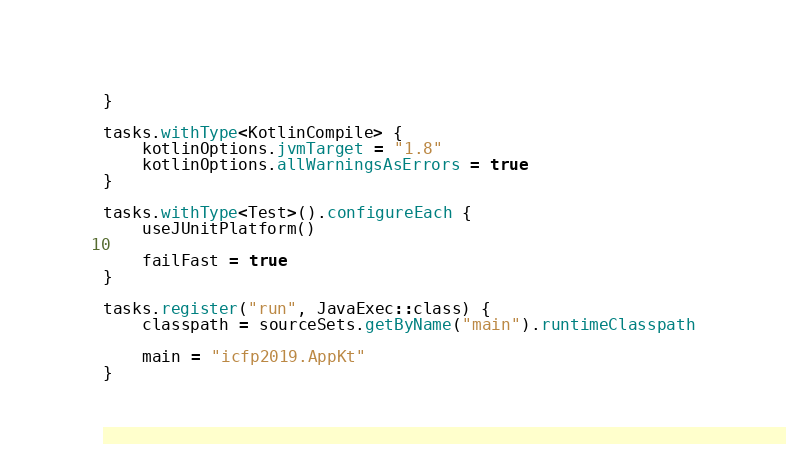Convert code to text. <code><loc_0><loc_0><loc_500><loc_500><_Kotlin_>}

tasks.withType<KotlinCompile> {
    kotlinOptions.jvmTarget = "1.8"
    kotlinOptions.allWarningsAsErrors = true
}

tasks.withType<Test>().configureEach {
    useJUnitPlatform()

    failFast = true
}

tasks.register("run", JavaExec::class) {
    classpath = sourceSets.getByName("main").runtimeClasspath

    main = "icfp2019.AppKt"
}
</code> 